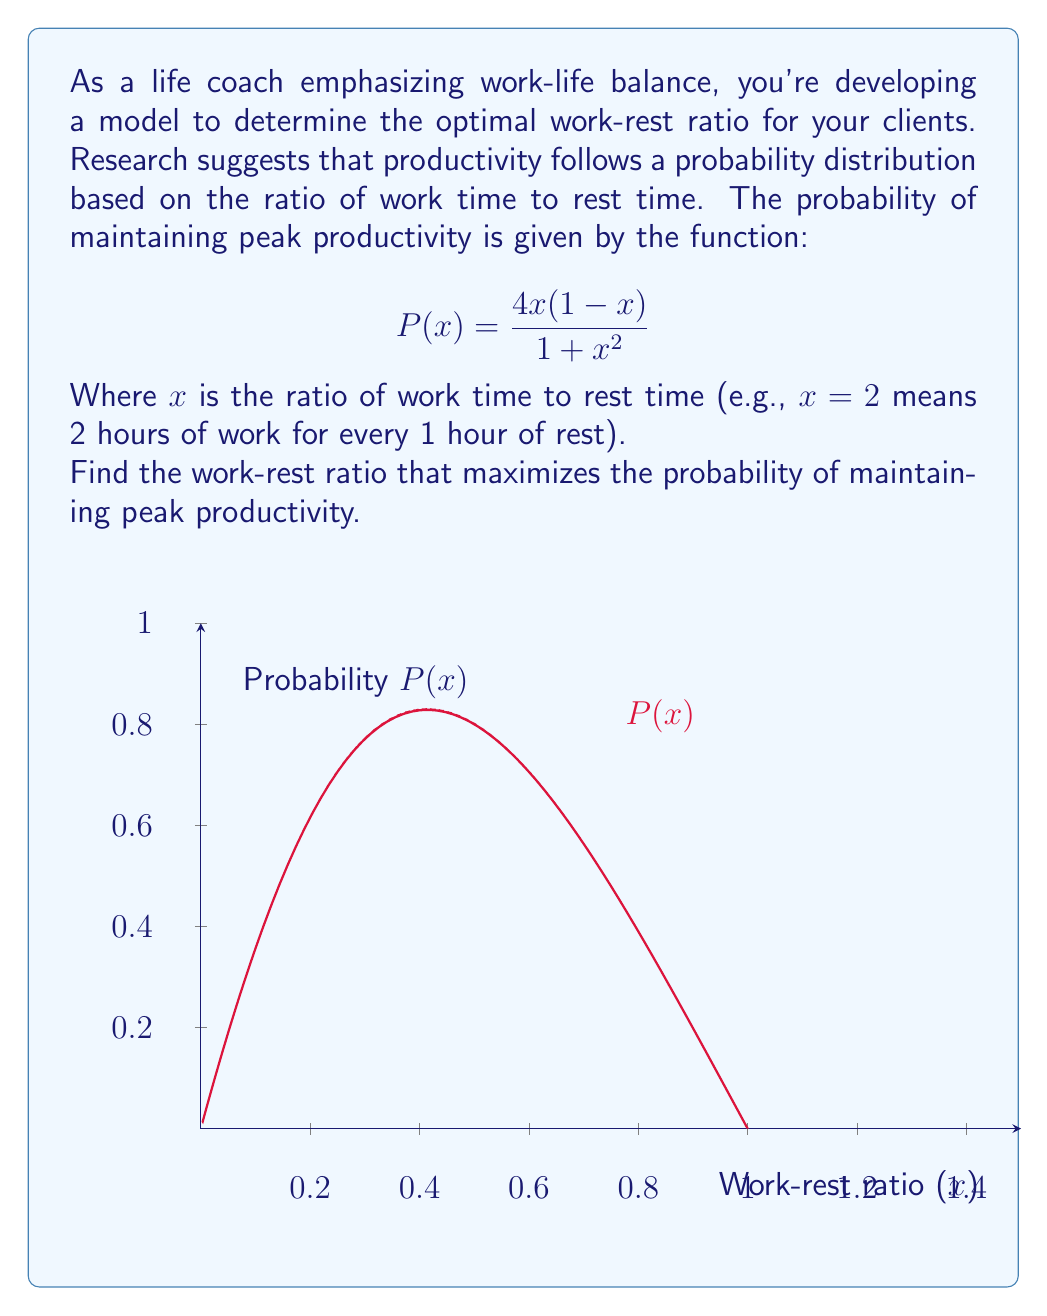Teach me how to tackle this problem. To find the maximum of the probability function, we need to find where its derivative equals zero:

1) First, let's calculate the derivative of $P(x)$ using the quotient rule:

   $$P'(x) = \frac{(1+x^2)(4-8x) - (4x(1-x))(2x)}{(1+x^2)^2}$$

2) Simplify the numerator:

   $$P'(x) = \frac{4+4x^2-8x-8x^3+8x^2-8x^3}{(1+x^2)^2}$$
   $$P'(x) = \frac{4+12x^2-8x-16x^3}{(1+x^2)^2}$$

3) Set the derivative equal to zero and solve:

   $$4+12x^2-8x-16x^3 = 0$$

4) This is a cubic equation. Let's factor out 4:

   $$4(1+3x^2-2x-4x^3) = 0$$

5) The solution to this equation is $x = \frac{1}{\sqrt{3}}$

6) To confirm this is a maximum, we can check the second derivative is negative at this point or observe the graph.

Therefore, the optimal work-rest ratio is $1:\frac{1}{\sqrt{3}}$, or approximately 1:0.577.
Answer: $\frac{1}{\sqrt{3}}$ : 1 